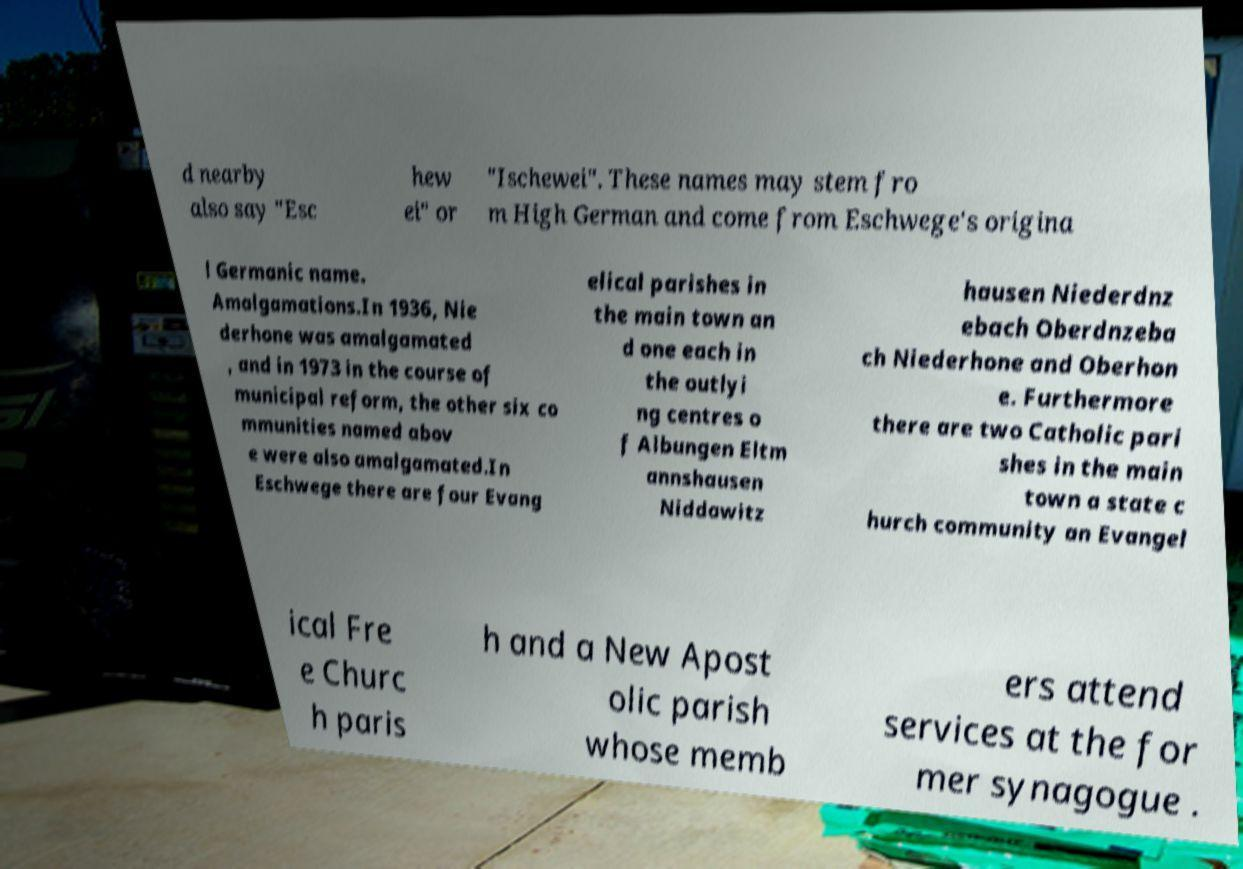I need the written content from this picture converted into text. Can you do that? d nearby also say "Esc hew ei" or "Ischewei". These names may stem fro m High German and come from Eschwege's origina l Germanic name. Amalgamations.In 1936, Nie derhone was amalgamated , and in 1973 in the course of municipal reform, the other six co mmunities named abov e were also amalgamated.In Eschwege there are four Evang elical parishes in the main town an d one each in the outlyi ng centres o f Albungen Eltm annshausen Niddawitz hausen Niederdnz ebach Oberdnzeba ch Niederhone and Oberhon e. Furthermore there are two Catholic pari shes in the main town a state c hurch community an Evangel ical Fre e Churc h paris h and a New Apost olic parish whose memb ers attend services at the for mer synagogue . 